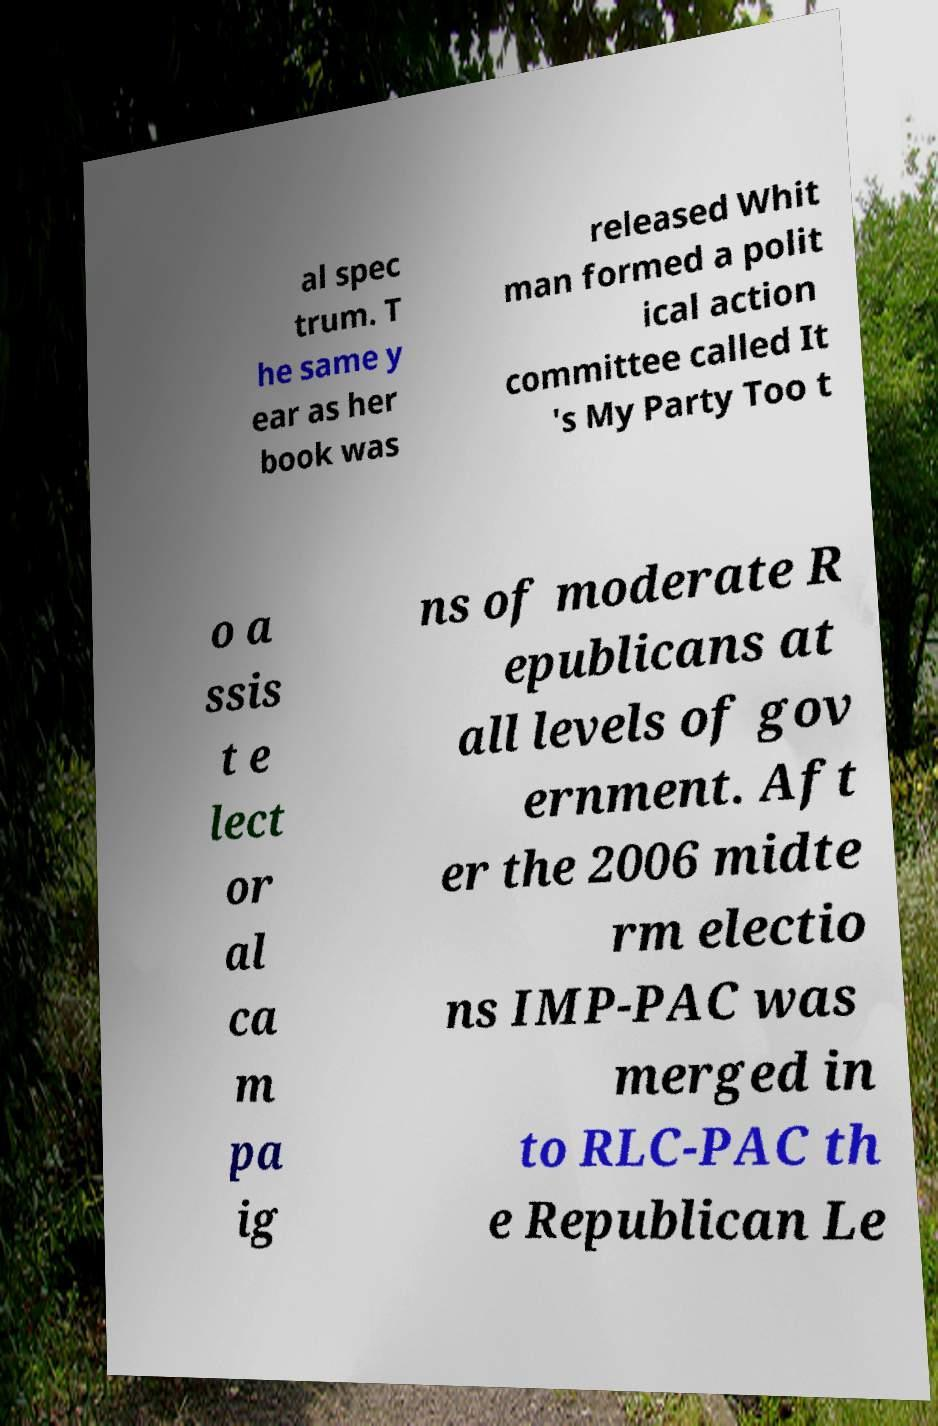Could you extract and type out the text from this image? al spec trum. T he same y ear as her book was released Whit man formed a polit ical action committee called It 's My Party Too t o a ssis t e lect or al ca m pa ig ns of moderate R epublicans at all levels of gov ernment. Aft er the 2006 midte rm electio ns IMP-PAC was merged in to RLC-PAC th e Republican Le 